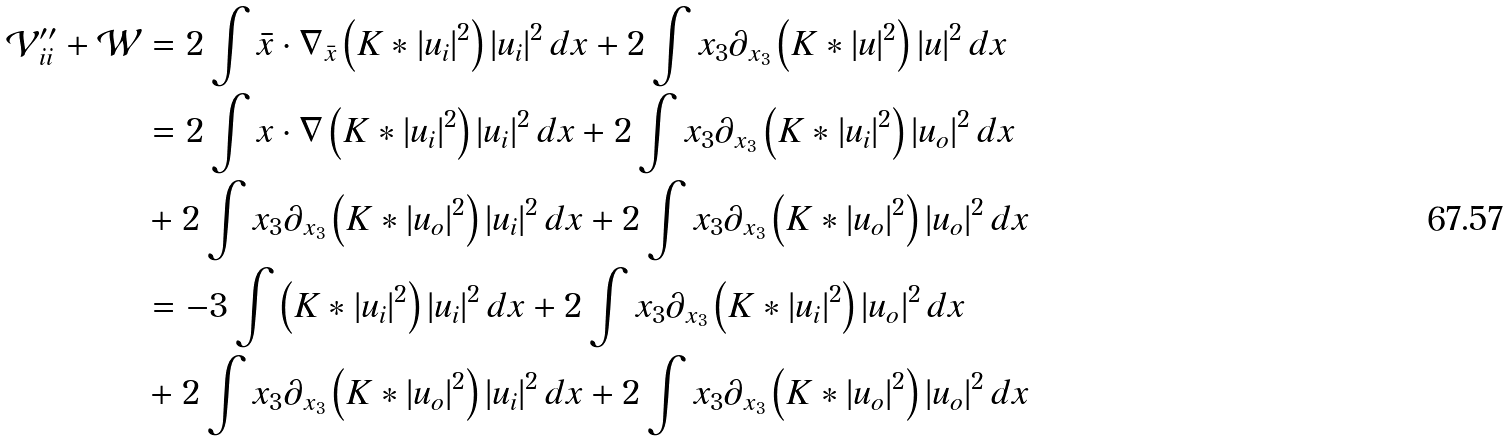Convert formula to latex. <formula><loc_0><loc_0><loc_500><loc_500>\mathcal { V } _ { i i } ^ { \prime \prime } + \mathcal { W } & = 2 \int \bar { x } \cdot \nabla _ { \bar { x } } \left ( K \ast | u _ { i } | ^ { 2 } \right ) | u _ { i } | ^ { 2 } \, d x + 2 \int x _ { 3 } \partial _ { x _ { 3 } } \left ( K \ast | u | ^ { 2 } \right ) | u | ^ { 2 } \, d x \\ & = 2 \int x \cdot \nabla \left ( K \ast | u _ { i } | ^ { 2 } \right ) | u _ { i } | ^ { 2 } \, d x + 2 \int x _ { 3 } \partial _ { x _ { 3 } } \left ( K \ast | u _ { i } | ^ { 2 } \right ) | u _ { o } | ^ { 2 } \, d x \\ & + 2 \int x _ { 3 } \partial _ { x _ { 3 } } \left ( K \ast | u _ { o } | ^ { 2 } \right ) | u _ { i } | ^ { 2 } \, d x + 2 \int x _ { 3 } \partial _ { x _ { 3 } } \left ( K \ast | u _ { o } | ^ { 2 } \right ) | u _ { o } | ^ { 2 } \, d x \\ & = - 3 \int \left ( K \ast | u _ { i } | ^ { 2 } \right ) | u _ { i } | ^ { 2 } \, d x + 2 \int x _ { 3 } \partial _ { x _ { 3 } } \left ( K \ast | u _ { i } | ^ { 2 } \right ) | u _ { o } | ^ { 2 } \, d x \\ & + 2 \int x _ { 3 } \partial _ { x _ { 3 } } \left ( K \ast | u _ { o } | ^ { 2 } \right ) | u _ { i } | ^ { 2 } \, d x + 2 \int x _ { 3 } \partial _ { x _ { 3 } } \left ( K \ast | u _ { o } | ^ { 2 } \right ) | u _ { o } | ^ { 2 } \, d x</formula> 